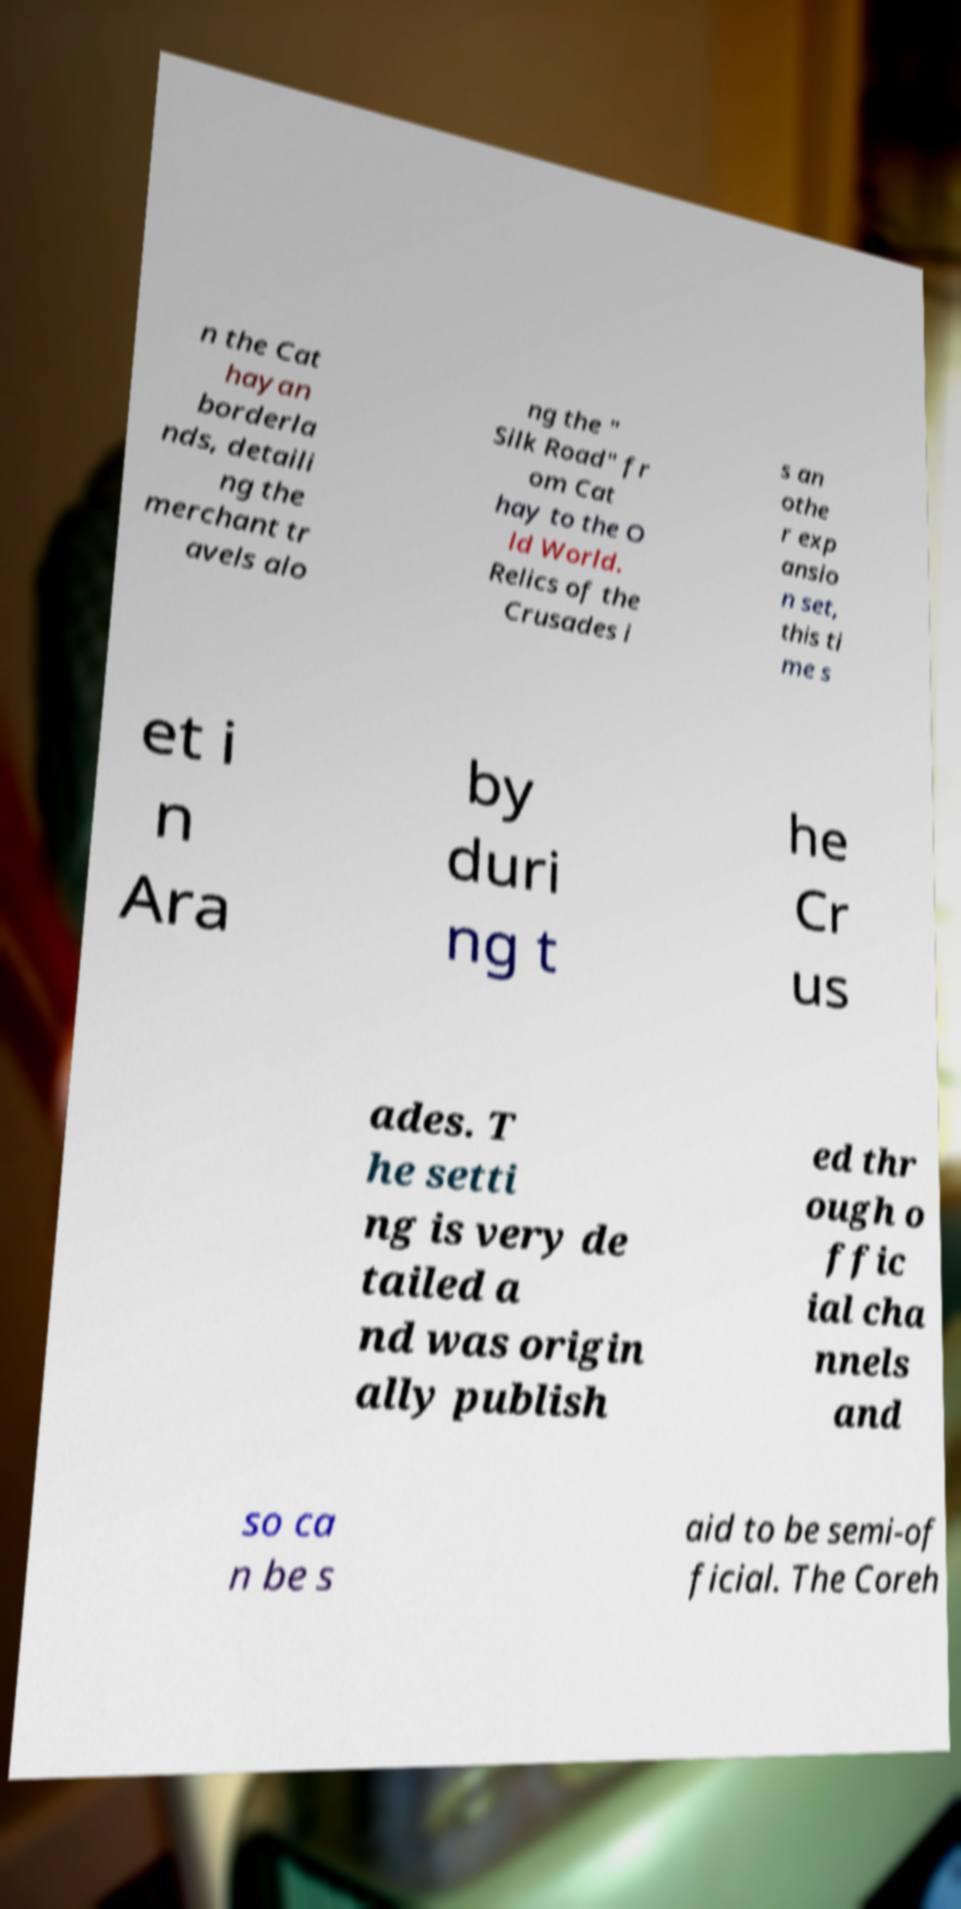There's text embedded in this image that I need extracted. Can you transcribe it verbatim? n the Cat hayan borderla nds, detaili ng the merchant tr avels alo ng the " Silk Road" fr om Cat hay to the O ld World. Relics of the Crusades i s an othe r exp ansio n set, this ti me s et i n Ara by duri ng t he Cr us ades. T he setti ng is very de tailed a nd was origin ally publish ed thr ough o ffic ial cha nnels and so ca n be s aid to be semi-of ficial. The Coreh 